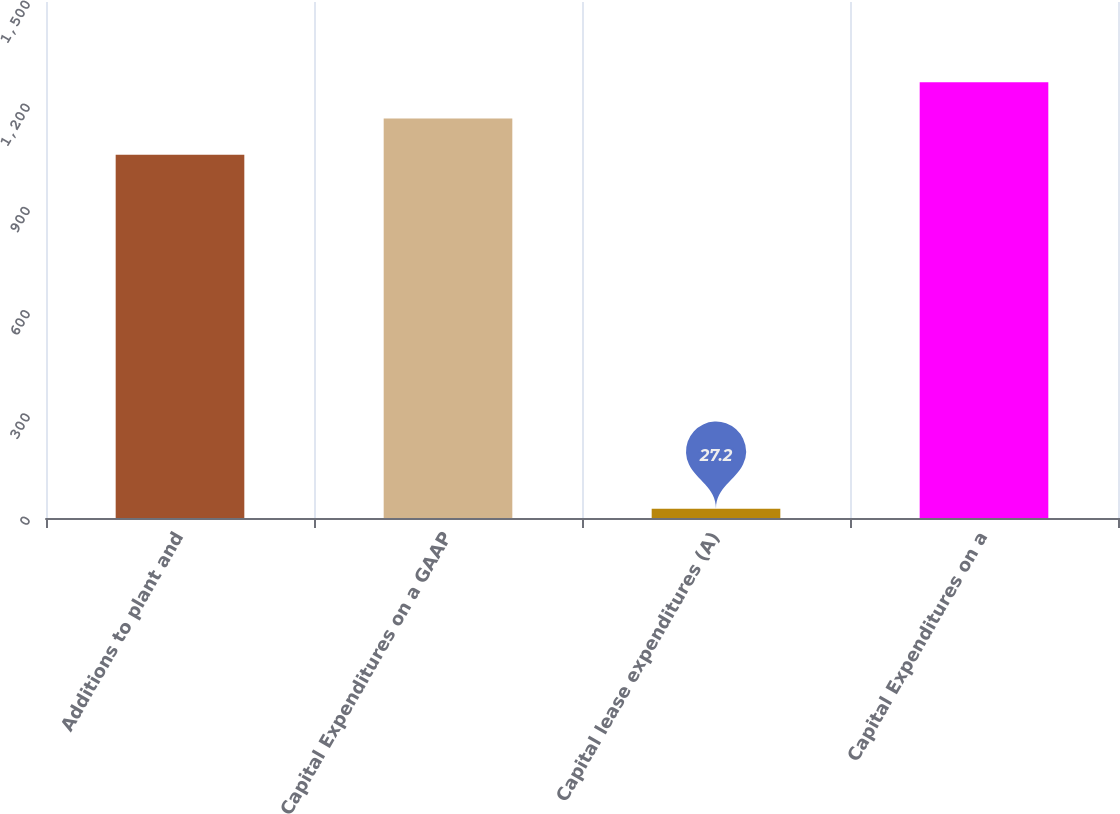<chart> <loc_0><loc_0><loc_500><loc_500><bar_chart><fcel>Additions to plant and<fcel>Capital Expenditures on a GAAP<fcel>Capital lease expenditures (A)<fcel>Capital Expenditures on a<nl><fcel>1055.8<fcel>1161.38<fcel>27.2<fcel>1266.96<nl></chart> 